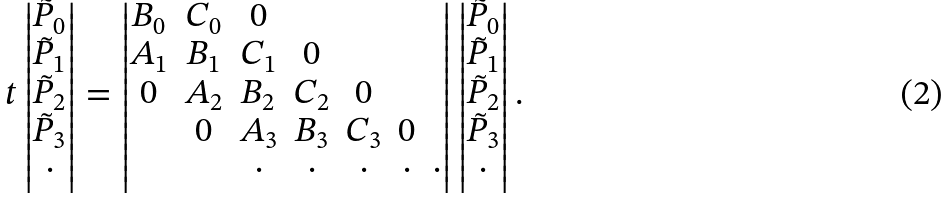Convert formula to latex. <formula><loc_0><loc_0><loc_500><loc_500>t \begin{vmatrix} \tilde { P } _ { 0 } \\ \tilde { P } _ { 1 } \\ \tilde { P } _ { 2 } \\ \tilde { P } _ { 3 } \\ \cdot \end{vmatrix} = \begin{vmatrix} B _ { 0 } & C _ { 0 } & 0 & \\ A _ { 1 } & B _ { 1 } & C _ { 1 } & 0 & \\ 0 & A _ { 2 } & B _ { 2 } & C _ { 2 } & 0 & \\ & 0 & A _ { 3 } & B _ { 3 } & C _ { 3 } & 0 \\ & & \cdot & \cdot & \cdot & \cdot & \cdot \end{vmatrix} \begin{vmatrix} \tilde { P } _ { 0 } \\ \tilde { P } _ { 1 } \\ \tilde { P } _ { 2 } \\ \tilde { P } _ { 3 } \\ \cdot \end{vmatrix} .</formula> 